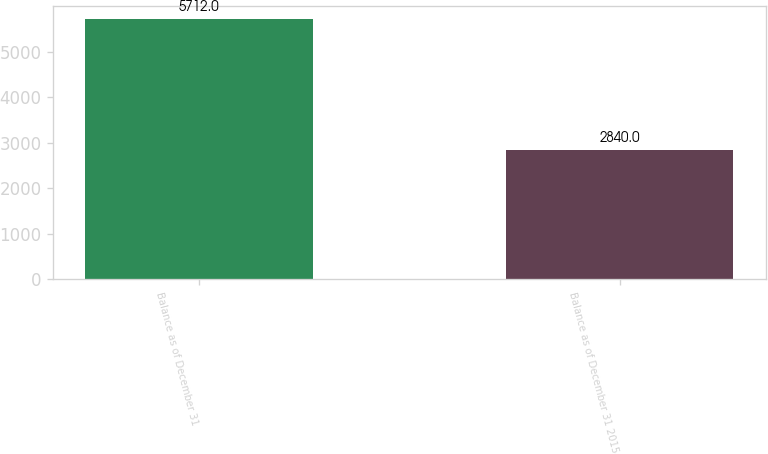Convert chart to OTSL. <chart><loc_0><loc_0><loc_500><loc_500><bar_chart><fcel>Balance as of December 31<fcel>Balance as of December 31 2015<nl><fcel>5712<fcel>2840<nl></chart> 